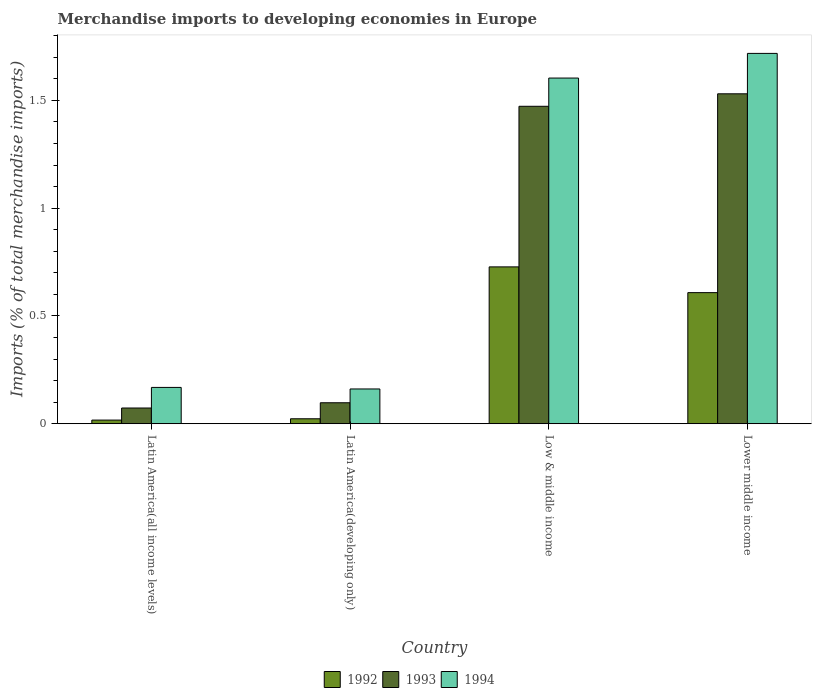Are the number of bars per tick equal to the number of legend labels?
Offer a terse response. Yes. Are the number of bars on each tick of the X-axis equal?
Your answer should be compact. Yes. What is the label of the 2nd group of bars from the left?
Give a very brief answer. Latin America(developing only). In how many cases, is the number of bars for a given country not equal to the number of legend labels?
Keep it short and to the point. 0. What is the percentage total merchandise imports in 1992 in Latin America(all income levels)?
Give a very brief answer. 0.02. Across all countries, what is the maximum percentage total merchandise imports in 1994?
Keep it short and to the point. 1.72. Across all countries, what is the minimum percentage total merchandise imports in 1993?
Provide a short and direct response. 0.07. In which country was the percentage total merchandise imports in 1993 maximum?
Provide a succinct answer. Lower middle income. In which country was the percentage total merchandise imports in 1993 minimum?
Provide a short and direct response. Latin America(all income levels). What is the total percentage total merchandise imports in 1993 in the graph?
Your answer should be very brief. 3.17. What is the difference between the percentage total merchandise imports in 1992 in Latin America(all income levels) and that in Lower middle income?
Provide a short and direct response. -0.59. What is the difference between the percentage total merchandise imports in 1994 in Latin America(all income levels) and the percentage total merchandise imports in 1992 in Low & middle income?
Offer a very short reply. -0.56. What is the average percentage total merchandise imports in 1994 per country?
Provide a succinct answer. 0.91. What is the difference between the percentage total merchandise imports of/in 1993 and percentage total merchandise imports of/in 1994 in Latin America(developing only)?
Your answer should be very brief. -0.06. In how many countries, is the percentage total merchandise imports in 1992 greater than 1.5 %?
Your answer should be compact. 0. What is the ratio of the percentage total merchandise imports in 1993 in Latin America(developing only) to that in Low & middle income?
Provide a short and direct response. 0.07. What is the difference between the highest and the second highest percentage total merchandise imports in 1993?
Provide a succinct answer. -1.43. What is the difference between the highest and the lowest percentage total merchandise imports in 1994?
Give a very brief answer. 1.56. Is the sum of the percentage total merchandise imports in 1993 in Latin America(all income levels) and Latin America(developing only) greater than the maximum percentage total merchandise imports in 1992 across all countries?
Your response must be concise. No. What is the difference between two consecutive major ticks on the Y-axis?
Your answer should be compact. 0.5. Does the graph contain any zero values?
Give a very brief answer. No. Does the graph contain grids?
Keep it short and to the point. No. Where does the legend appear in the graph?
Your answer should be compact. Bottom center. What is the title of the graph?
Your answer should be very brief. Merchandise imports to developing economies in Europe. Does "2010" appear as one of the legend labels in the graph?
Your answer should be very brief. No. What is the label or title of the Y-axis?
Provide a succinct answer. Imports (% of total merchandise imports). What is the Imports (% of total merchandise imports) in 1992 in Latin America(all income levels)?
Your response must be concise. 0.02. What is the Imports (% of total merchandise imports) of 1993 in Latin America(all income levels)?
Offer a very short reply. 0.07. What is the Imports (% of total merchandise imports) in 1994 in Latin America(all income levels)?
Provide a succinct answer. 0.17. What is the Imports (% of total merchandise imports) in 1992 in Latin America(developing only)?
Offer a terse response. 0.02. What is the Imports (% of total merchandise imports) in 1993 in Latin America(developing only)?
Offer a very short reply. 0.1. What is the Imports (% of total merchandise imports) of 1994 in Latin America(developing only)?
Your response must be concise. 0.16. What is the Imports (% of total merchandise imports) in 1992 in Low & middle income?
Offer a very short reply. 0.73. What is the Imports (% of total merchandise imports) in 1993 in Low & middle income?
Give a very brief answer. 1.47. What is the Imports (% of total merchandise imports) in 1994 in Low & middle income?
Offer a terse response. 1.6. What is the Imports (% of total merchandise imports) in 1992 in Lower middle income?
Offer a very short reply. 0.61. What is the Imports (% of total merchandise imports) of 1993 in Lower middle income?
Make the answer very short. 1.53. What is the Imports (% of total merchandise imports) of 1994 in Lower middle income?
Provide a succinct answer. 1.72. Across all countries, what is the maximum Imports (% of total merchandise imports) in 1992?
Provide a succinct answer. 0.73. Across all countries, what is the maximum Imports (% of total merchandise imports) of 1993?
Offer a very short reply. 1.53. Across all countries, what is the maximum Imports (% of total merchandise imports) of 1994?
Keep it short and to the point. 1.72. Across all countries, what is the minimum Imports (% of total merchandise imports) of 1992?
Provide a short and direct response. 0.02. Across all countries, what is the minimum Imports (% of total merchandise imports) in 1993?
Keep it short and to the point. 0.07. Across all countries, what is the minimum Imports (% of total merchandise imports) of 1994?
Provide a succinct answer. 0.16. What is the total Imports (% of total merchandise imports) in 1992 in the graph?
Ensure brevity in your answer.  1.38. What is the total Imports (% of total merchandise imports) in 1993 in the graph?
Make the answer very short. 3.17. What is the total Imports (% of total merchandise imports) of 1994 in the graph?
Provide a succinct answer. 3.65. What is the difference between the Imports (% of total merchandise imports) of 1992 in Latin America(all income levels) and that in Latin America(developing only)?
Give a very brief answer. -0.01. What is the difference between the Imports (% of total merchandise imports) of 1993 in Latin America(all income levels) and that in Latin America(developing only)?
Ensure brevity in your answer.  -0.02. What is the difference between the Imports (% of total merchandise imports) of 1994 in Latin America(all income levels) and that in Latin America(developing only)?
Offer a terse response. 0.01. What is the difference between the Imports (% of total merchandise imports) in 1992 in Latin America(all income levels) and that in Low & middle income?
Provide a short and direct response. -0.71. What is the difference between the Imports (% of total merchandise imports) of 1993 in Latin America(all income levels) and that in Low & middle income?
Your answer should be very brief. -1.4. What is the difference between the Imports (% of total merchandise imports) of 1994 in Latin America(all income levels) and that in Low & middle income?
Your answer should be very brief. -1.44. What is the difference between the Imports (% of total merchandise imports) of 1992 in Latin America(all income levels) and that in Lower middle income?
Provide a succinct answer. -0.59. What is the difference between the Imports (% of total merchandise imports) of 1993 in Latin America(all income levels) and that in Lower middle income?
Offer a very short reply. -1.46. What is the difference between the Imports (% of total merchandise imports) in 1994 in Latin America(all income levels) and that in Lower middle income?
Keep it short and to the point. -1.55. What is the difference between the Imports (% of total merchandise imports) of 1992 in Latin America(developing only) and that in Low & middle income?
Make the answer very short. -0.7. What is the difference between the Imports (% of total merchandise imports) in 1993 in Latin America(developing only) and that in Low & middle income?
Your answer should be compact. -1.38. What is the difference between the Imports (% of total merchandise imports) in 1994 in Latin America(developing only) and that in Low & middle income?
Offer a terse response. -1.44. What is the difference between the Imports (% of total merchandise imports) of 1992 in Latin America(developing only) and that in Lower middle income?
Make the answer very short. -0.59. What is the difference between the Imports (% of total merchandise imports) of 1993 in Latin America(developing only) and that in Lower middle income?
Ensure brevity in your answer.  -1.43. What is the difference between the Imports (% of total merchandise imports) of 1994 in Latin America(developing only) and that in Lower middle income?
Your answer should be compact. -1.56. What is the difference between the Imports (% of total merchandise imports) of 1992 in Low & middle income and that in Lower middle income?
Provide a succinct answer. 0.12. What is the difference between the Imports (% of total merchandise imports) of 1993 in Low & middle income and that in Lower middle income?
Your response must be concise. -0.06. What is the difference between the Imports (% of total merchandise imports) in 1994 in Low & middle income and that in Lower middle income?
Your answer should be compact. -0.11. What is the difference between the Imports (% of total merchandise imports) of 1992 in Latin America(all income levels) and the Imports (% of total merchandise imports) of 1993 in Latin America(developing only)?
Provide a short and direct response. -0.08. What is the difference between the Imports (% of total merchandise imports) of 1992 in Latin America(all income levels) and the Imports (% of total merchandise imports) of 1994 in Latin America(developing only)?
Provide a short and direct response. -0.14. What is the difference between the Imports (% of total merchandise imports) in 1993 in Latin America(all income levels) and the Imports (% of total merchandise imports) in 1994 in Latin America(developing only)?
Keep it short and to the point. -0.09. What is the difference between the Imports (% of total merchandise imports) in 1992 in Latin America(all income levels) and the Imports (% of total merchandise imports) in 1993 in Low & middle income?
Provide a short and direct response. -1.46. What is the difference between the Imports (% of total merchandise imports) of 1992 in Latin America(all income levels) and the Imports (% of total merchandise imports) of 1994 in Low & middle income?
Your answer should be very brief. -1.59. What is the difference between the Imports (% of total merchandise imports) in 1993 in Latin America(all income levels) and the Imports (% of total merchandise imports) in 1994 in Low & middle income?
Keep it short and to the point. -1.53. What is the difference between the Imports (% of total merchandise imports) in 1992 in Latin America(all income levels) and the Imports (% of total merchandise imports) in 1993 in Lower middle income?
Ensure brevity in your answer.  -1.51. What is the difference between the Imports (% of total merchandise imports) of 1992 in Latin America(all income levels) and the Imports (% of total merchandise imports) of 1994 in Lower middle income?
Provide a short and direct response. -1.7. What is the difference between the Imports (% of total merchandise imports) in 1993 in Latin America(all income levels) and the Imports (% of total merchandise imports) in 1994 in Lower middle income?
Provide a succinct answer. -1.65. What is the difference between the Imports (% of total merchandise imports) of 1992 in Latin America(developing only) and the Imports (% of total merchandise imports) of 1993 in Low & middle income?
Give a very brief answer. -1.45. What is the difference between the Imports (% of total merchandise imports) of 1992 in Latin America(developing only) and the Imports (% of total merchandise imports) of 1994 in Low & middle income?
Provide a short and direct response. -1.58. What is the difference between the Imports (% of total merchandise imports) in 1993 in Latin America(developing only) and the Imports (% of total merchandise imports) in 1994 in Low & middle income?
Your answer should be compact. -1.51. What is the difference between the Imports (% of total merchandise imports) in 1992 in Latin America(developing only) and the Imports (% of total merchandise imports) in 1993 in Lower middle income?
Your response must be concise. -1.51. What is the difference between the Imports (% of total merchandise imports) of 1992 in Latin America(developing only) and the Imports (% of total merchandise imports) of 1994 in Lower middle income?
Provide a succinct answer. -1.7. What is the difference between the Imports (% of total merchandise imports) of 1993 in Latin America(developing only) and the Imports (% of total merchandise imports) of 1994 in Lower middle income?
Offer a terse response. -1.62. What is the difference between the Imports (% of total merchandise imports) of 1992 in Low & middle income and the Imports (% of total merchandise imports) of 1993 in Lower middle income?
Your answer should be compact. -0.8. What is the difference between the Imports (% of total merchandise imports) in 1992 in Low & middle income and the Imports (% of total merchandise imports) in 1994 in Lower middle income?
Your answer should be compact. -0.99. What is the difference between the Imports (% of total merchandise imports) of 1993 in Low & middle income and the Imports (% of total merchandise imports) of 1994 in Lower middle income?
Ensure brevity in your answer.  -0.25. What is the average Imports (% of total merchandise imports) of 1992 per country?
Give a very brief answer. 0.34. What is the average Imports (% of total merchandise imports) in 1993 per country?
Your answer should be very brief. 0.79. What is the average Imports (% of total merchandise imports) in 1994 per country?
Give a very brief answer. 0.91. What is the difference between the Imports (% of total merchandise imports) in 1992 and Imports (% of total merchandise imports) in 1993 in Latin America(all income levels)?
Make the answer very short. -0.06. What is the difference between the Imports (% of total merchandise imports) of 1992 and Imports (% of total merchandise imports) of 1994 in Latin America(all income levels)?
Make the answer very short. -0.15. What is the difference between the Imports (% of total merchandise imports) in 1993 and Imports (% of total merchandise imports) in 1994 in Latin America(all income levels)?
Offer a terse response. -0.1. What is the difference between the Imports (% of total merchandise imports) in 1992 and Imports (% of total merchandise imports) in 1993 in Latin America(developing only)?
Offer a terse response. -0.07. What is the difference between the Imports (% of total merchandise imports) in 1992 and Imports (% of total merchandise imports) in 1994 in Latin America(developing only)?
Provide a succinct answer. -0.14. What is the difference between the Imports (% of total merchandise imports) in 1993 and Imports (% of total merchandise imports) in 1994 in Latin America(developing only)?
Your answer should be compact. -0.06. What is the difference between the Imports (% of total merchandise imports) in 1992 and Imports (% of total merchandise imports) in 1993 in Low & middle income?
Give a very brief answer. -0.74. What is the difference between the Imports (% of total merchandise imports) of 1992 and Imports (% of total merchandise imports) of 1994 in Low & middle income?
Your answer should be compact. -0.88. What is the difference between the Imports (% of total merchandise imports) of 1993 and Imports (% of total merchandise imports) of 1994 in Low & middle income?
Your answer should be compact. -0.13. What is the difference between the Imports (% of total merchandise imports) of 1992 and Imports (% of total merchandise imports) of 1993 in Lower middle income?
Provide a succinct answer. -0.92. What is the difference between the Imports (% of total merchandise imports) of 1992 and Imports (% of total merchandise imports) of 1994 in Lower middle income?
Give a very brief answer. -1.11. What is the difference between the Imports (% of total merchandise imports) of 1993 and Imports (% of total merchandise imports) of 1994 in Lower middle income?
Give a very brief answer. -0.19. What is the ratio of the Imports (% of total merchandise imports) in 1992 in Latin America(all income levels) to that in Latin America(developing only)?
Your answer should be compact. 0.73. What is the ratio of the Imports (% of total merchandise imports) in 1993 in Latin America(all income levels) to that in Latin America(developing only)?
Your answer should be very brief. 0.75. What is the ratio of the Imports (% of total merchandise imports) of 1994 in Latin America(all income levels) to that in Latin America(developing only)?
Your answer should be compact. 1.04. What is the ratio of the Imports (% of total merchandise imports) in 1992 in Latin America(all income levels) to that in Low & middle income?
Your response must be concise. 0.02. What is the ratio of the Imports (% of total merchandise imports) of 1993 in Latin America(all income levels) to that in Low & middle income?
Your response must be concise. 0.05. What is the ratio of the Imports (% of total merchandise imports) in 1994 in Latin America(all income levels) to that in Low & middle income?
Provide a succinct answer. 0.11. What is the ratio of the Imports (% of total merchandise imports) of 1992 in Latin America(all income levels) to that in Lower middle income?
Ensure brevity in your answer.  0.03. What is the ratio of the Imports (% of total merchandise imports) of 1993 in Latin America(all income levels) to that in Lower middle income?
Offer a terse response. 0.05. What is the ratio of the Imports (% of total merchandise imports) of 1994 in Latin America(all income levels) to that in Lower middle income?
Keep it short and to the point. 0.1. What is the ratio of the Imports (% of total merchandise imports) in 1992 in Latin America(developing only) to that in Low & middle income?
Your answer should be very brief. 0.03. What is the ratio of the Imports (% of total merchandise imports) in 1993 in Latin America(developing only) to that in Low & middle income?
Make the answer very short. 0.07. What is the ratio of the Imports (% of total merchandise imports) in 1994 in Latin America(developing only) to that in Low & middle income?
Your response must be concise. 0.1. What is the ratio of the Imports (% of total merchandise imports) in 1992 in Latin America(developing only) to that in Lower middle income?
Your response must be concise. 0.04. What is the ratio of the Imports (% of total merchandise imports) of 1993 in Latin America(developing only) to that in Lower middle income?
Offer a very short reply. 0.06. What is the ratio of the Imports (% of total merchandise imports) of 1994 in Latin America(developing only) to that in Lower middle income?
Provide a succinct answer. 0.09. What is the ratio of the Imports (% of total merchandise imports) in 1992 in Low & middle income to that in Lower middle income?
Provide a succinct answer. 1.2. What is the ratio of the Imports (% of total merchandise imports) of 1993 in Low & middle income to that in Lower middle income?
Offer a very short reply. 0.96. What is the ratio of the Imports (% of total merchandise imports) in 1994 in Low & middle income to that in Lower middle income?
Provide a succinct answer. 0.93. What is the difference between the highest and the second highest Imports (% of total merchandise imports) of 1992?
Provide a succinct answer. 0.12. What is the difference between the highest and the second highest Imports (% of total merchandise imports) in 1993?
Give a very brief answer. 0.06. What is the difference between the highest and the second highest Imports (% of total merchandise imports) of 1994?
Offer a terse response. 0.11. What is the difference between the highest and the lowest Imports (% of total merchandise imports) in 1992?
Provide a succinct answer. 0.71. What is the difference between the highest and the lowest Imports (% of total merchandise imports) in 1993?
Ensure brevity in your answer.  1.46. What is the difference between the highest and the lowest Imports (% of total merchandise imports) in 1994?
Make the answer very short. 1.56. 